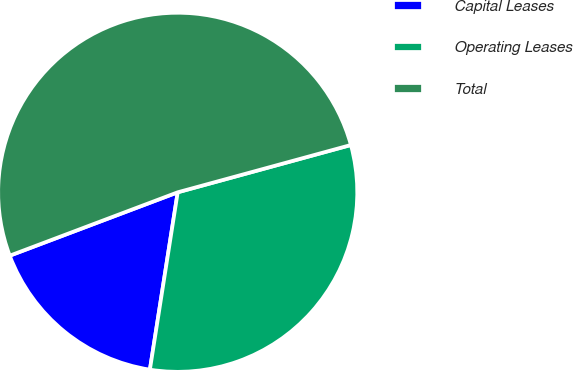<chart> <loc_0><loc_0><loc_500><loc_500><pie_chart><fcel>Capital Leases<fcel>Operating Leases<fcel>Total<nl><fcel>16.78%<fcel>31.72%<fcel>51.5%<nl></chart> 